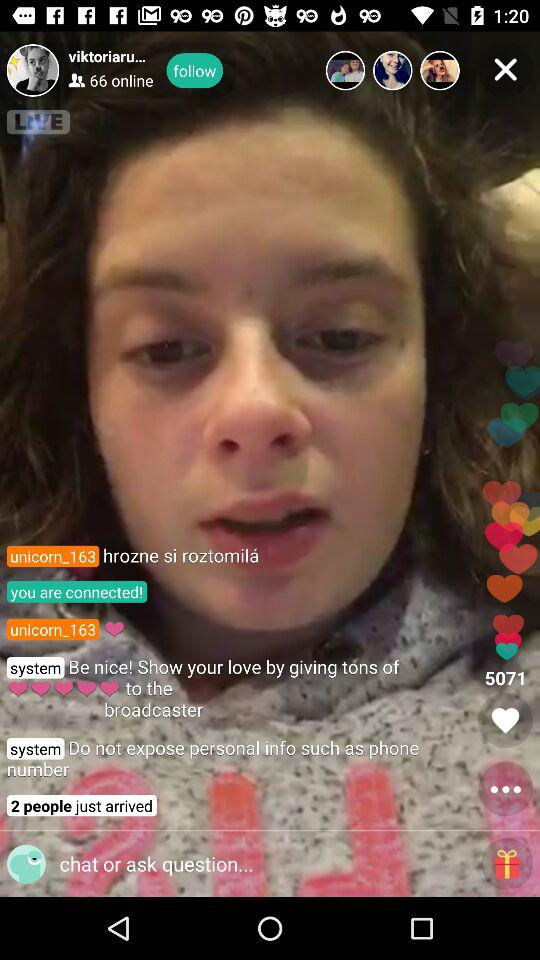How many people have just arrived? The number of people who have just arrived is 2. 